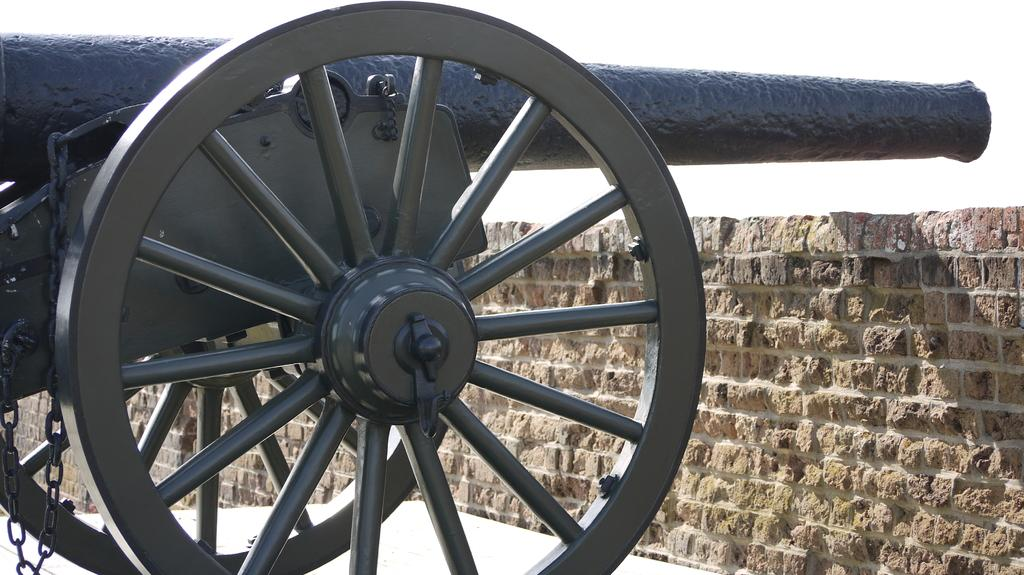What type of vehicle is in the image? There is a cannon vehicle in the image. What color is the cannon vehicle? The cannon vehicle is black in color. What is in front of the cannon vehicle? There is a brick wall in front of the cannon vehicle. What color is the background of the image? The background of the image is white. Where is the manager's office located in the image? There is no mention of a manager or an office in the image; it features a cannon vehicle with a brick wall in front of it and a white background. 